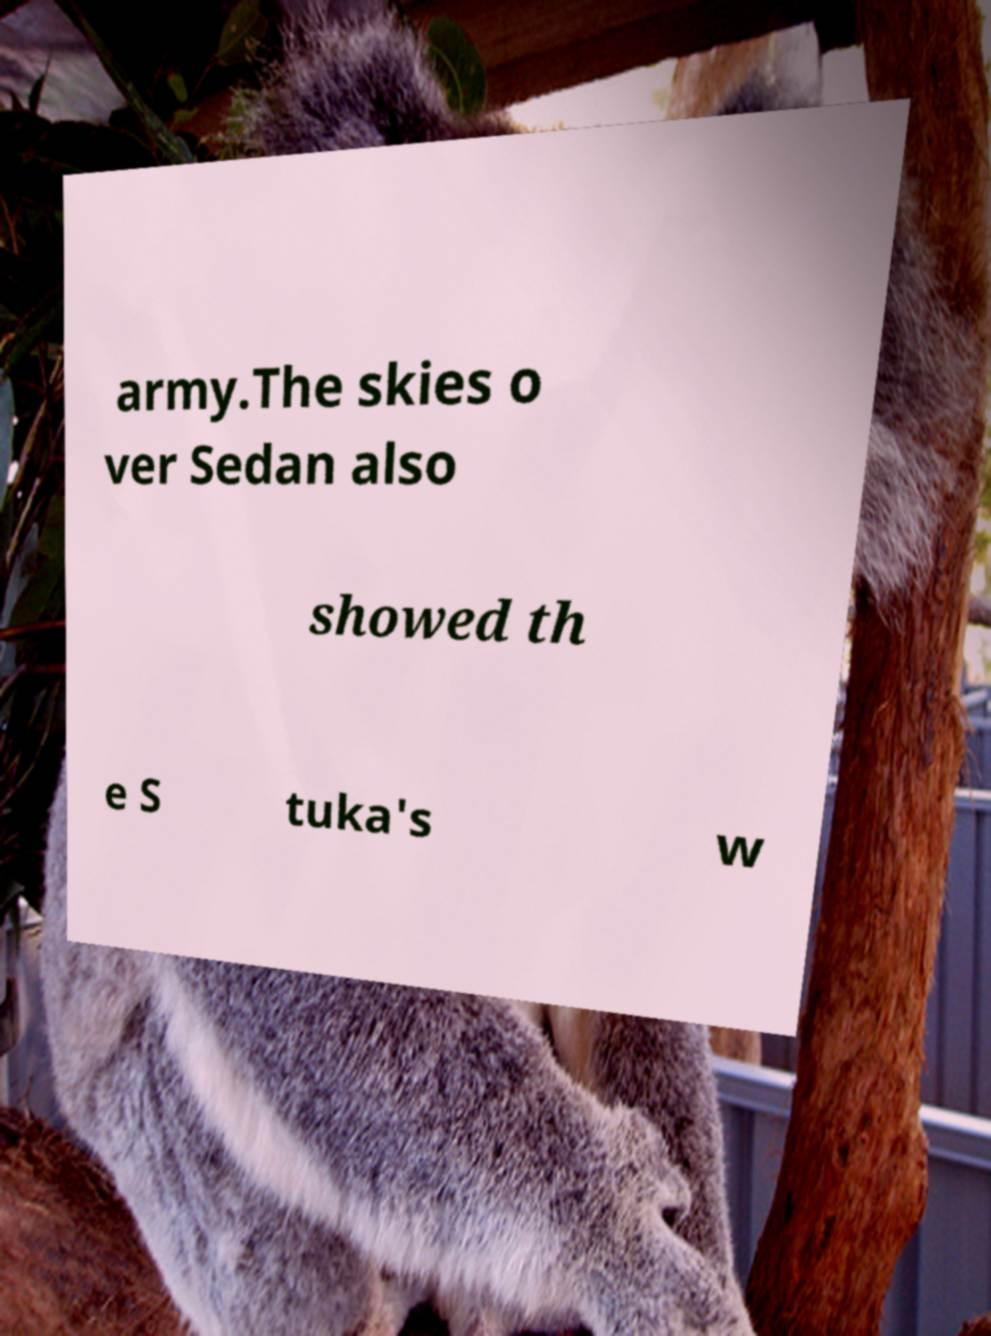Can you accurately transcribe the text from the provided image for me? army.The skies o ver Sedan also showed th e S tuka's w 